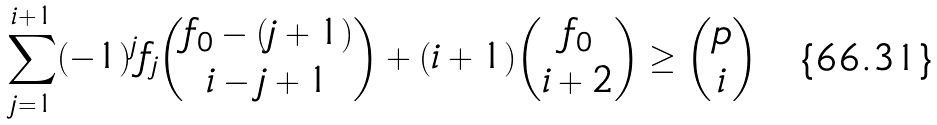<formula> <loc_0><loc_0><loc_500><loc_500>\sum _ { j = 1 } ^ { i + 1 } ( - 1 ) ^ { j } f _ { j } { f _ { 0 } - ( j + 1 ) \choose i - j + 1 } + ( i + 1 ) { f _ { 0 } \choose i + 2 } \geq { p \choose i }</formula> 